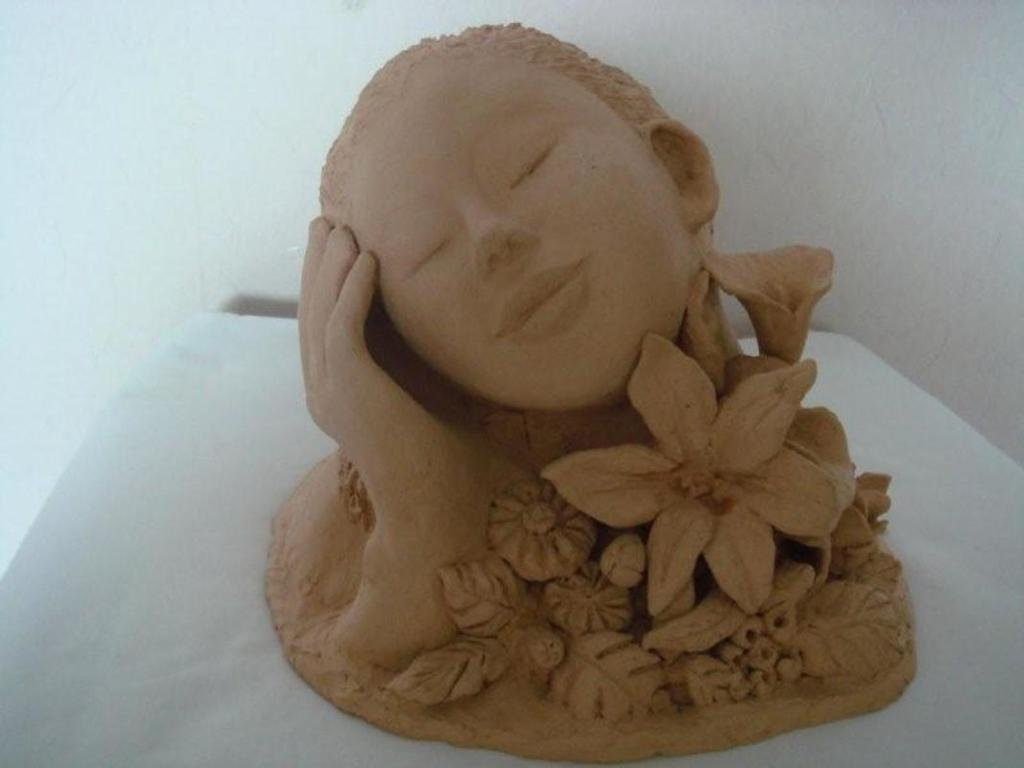What is the main subject of the image? There is a sculpture in the image. What is the color of the surface on which the sculpture is placed? The sculpture is on a white surface. What can be seen in the background of the image? There is a white wall in the background of the image. What purpose does the sculpture serve in the image? The purpose of the sculpture cannot be determined from the image alone, as it may be a decorative piece or have a symbolic meaning. 